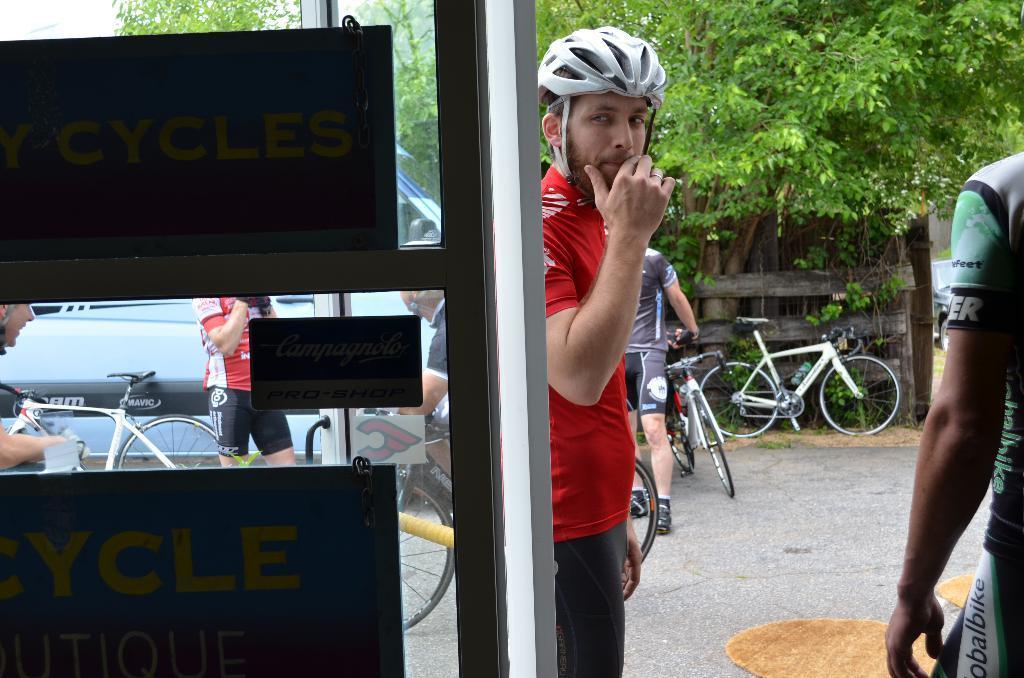Can you describe this image briefly? In this image I can see two boards, the glass surface, a person wearing red and black colored dress and white helmet and another person wearing green, white and black colored dress are standing. In the background I can see few bicycles, few persons, few vehicles, few trees, the wooden railing and the sky. 